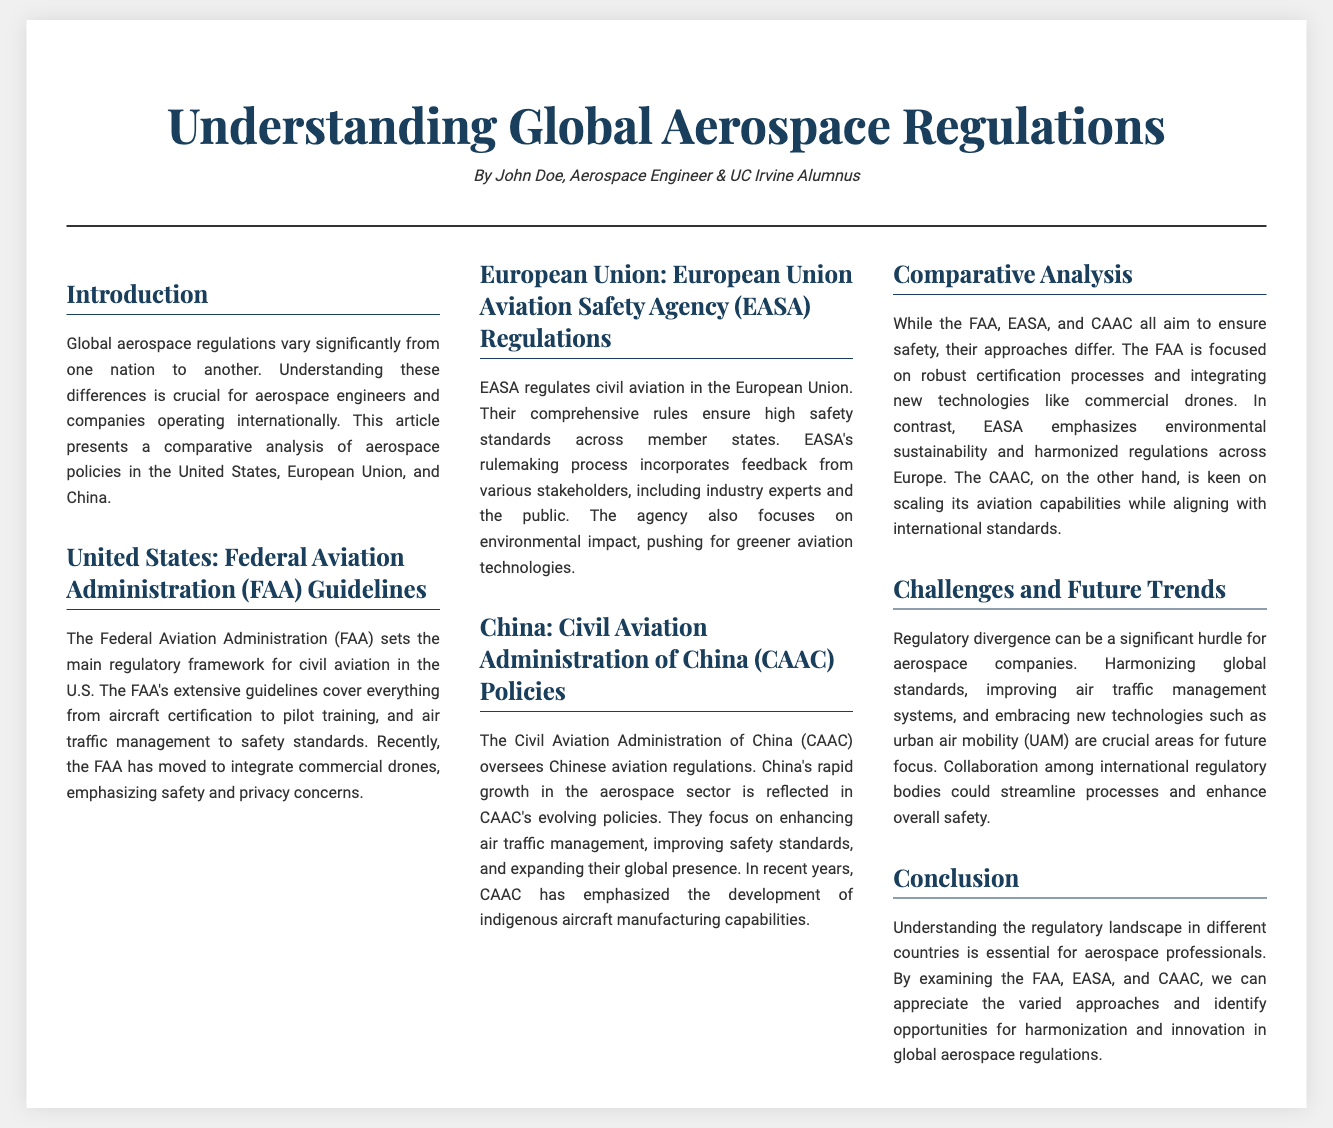What is the title of the article? The title of the article is prominently featured at the top of the document.
Answer: Understanding Global Aerospace Regulations Who is the author of the article? The author's name is mentioned in the header, indicating their credentials.
Answer: John Doe Which agency regulates civil aviation in the European Union? This regulation agency is specifically addressed in the section detailing EASA.
Answer: European Union Aviation Safety Agency What is the primary focus of the FAA's recent regulations? The focus of the FAA’s recent regulations is described in terms of integrating new technologies and concerns.
Answer: commercial drones How many nations’ aerospace policies are analyzed in the document? The document clearly states the number of nations covered in the comparative analysis section.
Answer: Three What is the main challenge for aerospace companies mentioned in the article? The challenges faced by aerospace companies are summarized in the section addressing future trends.
Answer: Regulatory divergence In which section is the comparative analysis of FAA, EASA, and CAAC conducted? The document includes a specific section that compares these agencies' regulations.
Answer: Comparative Analysis What type of technology is specifically mentioned as part of future trends? The document lists this particular technology as a significant focus for future regulatory trends.
Answer: urban air mobility (UAM) 